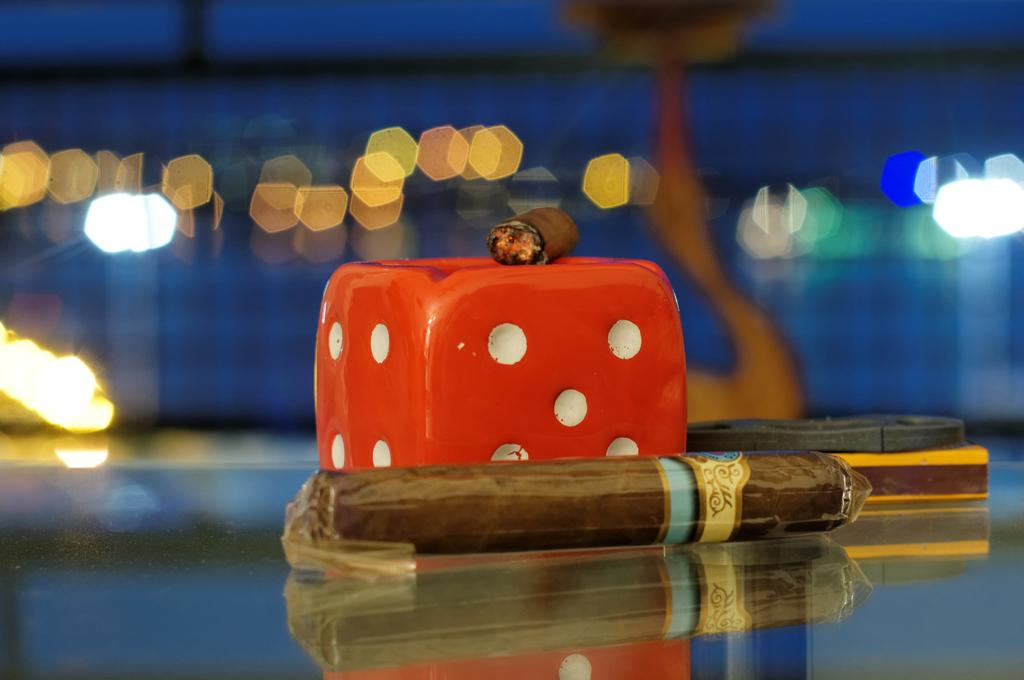What objects can be seen on the glass table in the image? There are dice, a cigar, and a lighter on the glass table in the image. What might be used to ignite the cigar in the image? The lighter in the image can be used to ignite the cigar. What is the condition of the background in the image? The background appears blurry in the image. What can be seen in the background of the image? There are lights visible in the background of the image. What type of coal is being used to whistle in the image? There is no coal or whistling present in the image. Is there any indication of an attack happening in the image? No, there is no indication of an attack in the image. 